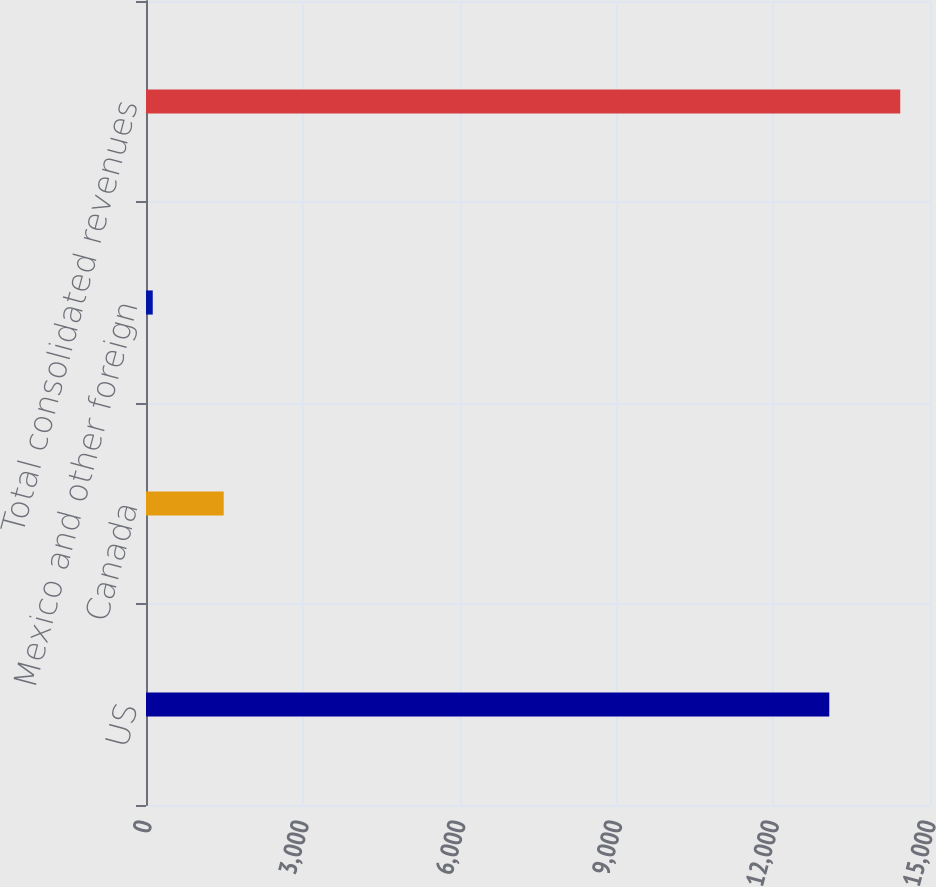Convert chart. <chart><loc_0><loc_0><loc_500><loc_500><bar_chart><fcel>US<fcel>Canada<fcel>Mexico and other foreign<fcel>Total consolidated revenues<nl><fcel>13073<fcel>1486.6<fcel>129<fcel>14430.6<nl></chart> 